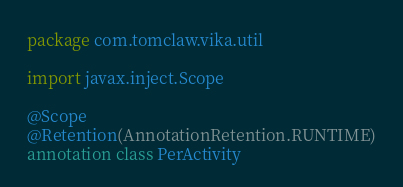<code> <loc_0><loc_0><loc_500><loc_500><_Kotlin_>package com.tomclaw.vika.util

import javax.inject.Scope

@Scope
@Retention(AnnotationRetention.RUNTIME)
annotation class PerActivity

</code> 